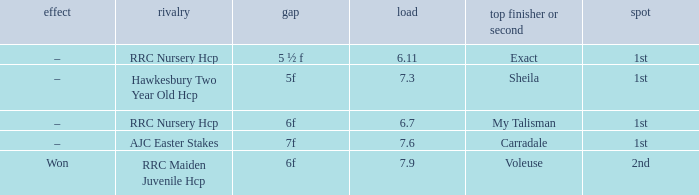What is the largest weight wth a Result of –, and a Distance of 7f? 7.6. Parse the table in full. {'header': ['effect', 'rivalry', 'gap', 'load', 'top finisher or second', 'spot'], 'rows': [['–', 'RRC Nursery Hcp', '5 ½ f', '6.11', 'Exact', '1st'], ['–', 'Hawkesbury Two Year Old Hcp', '5f', '7.3', 'Sheila', '1st'], ['–', 'RRC Nursery Hcp', '6f', '6.7', 'My Talisman', '1st'], ['–', 'AJC Easter Stakes', '7f', '7.6', 'Carradale', '1st'], ['Won', 'RRC Maiden Juvenile Hcp', '6f', '7.9', 'Voleuse', '2nd']]} 